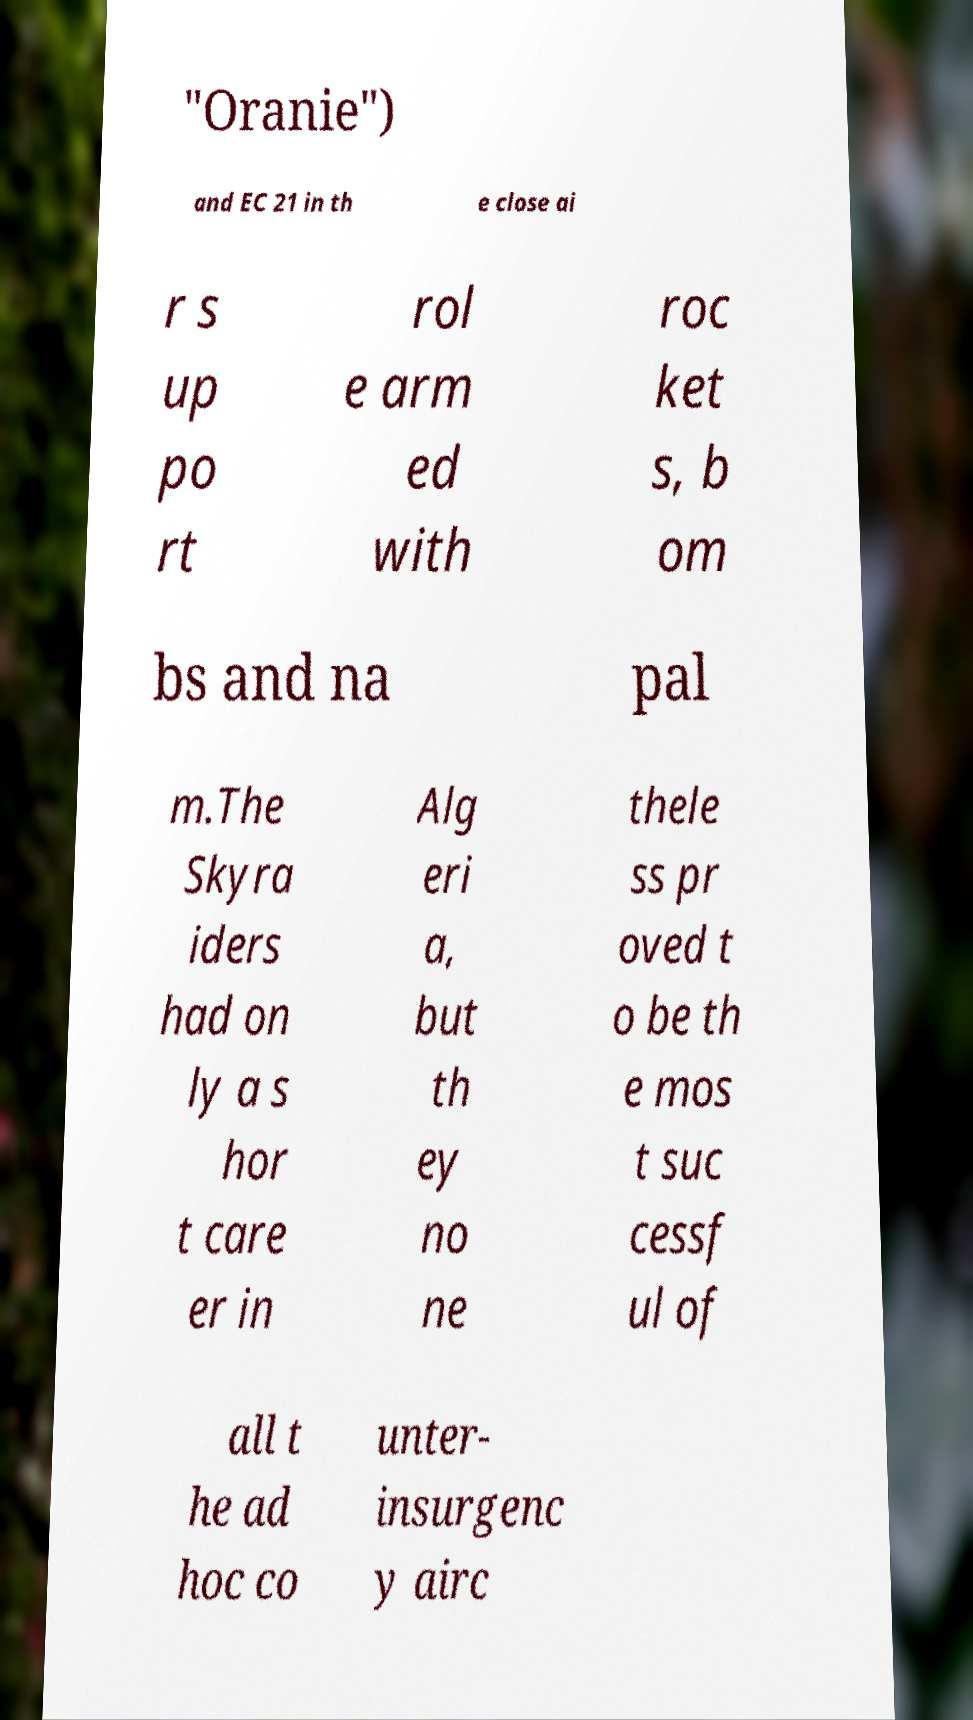Please identify and transcribe the text found in this image. "Oranie") and EC 21 in th e close ai r s up po rt rol e arm ed with roc ket s, b om bs and na pal m.The Skyra iders had on ly a s hor t care er in Alg eri a, but th ey no ne thele ss pr oved t o be th e mos t suc cessf ul of all t he ad hoc co unter- insurgenc y airc 